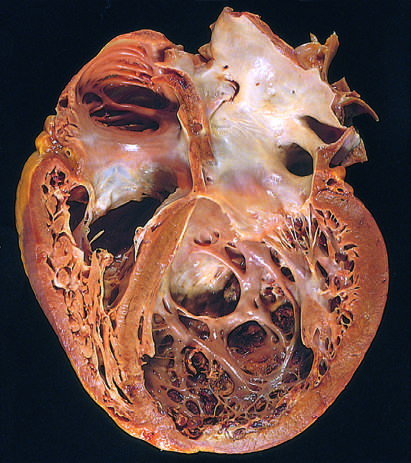re four-chamber dilation and hypertrophy evident?
Answer the question using a single word or phrase. Yes 